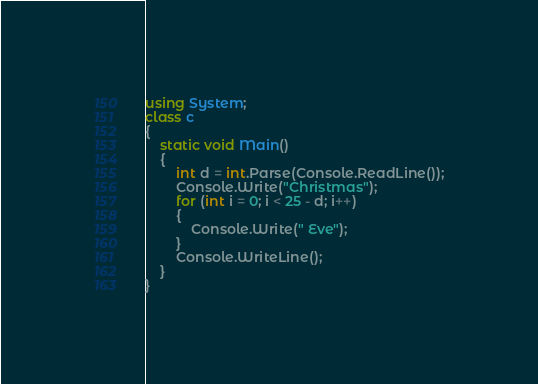Convert code to text. <code><loc_0><loc_0><loc_500><loc_500><_C#_>using System;
class c
{
    static void Main()
    {
        int d = int.Parse(Console.ReadLine());
        Console.Write("Christmas");
        for (int i = 0; i < 25 - d; i++)
        {
            Console.Write(" Eve");
        }
        Console.WriteLine();
    }
}</code> 